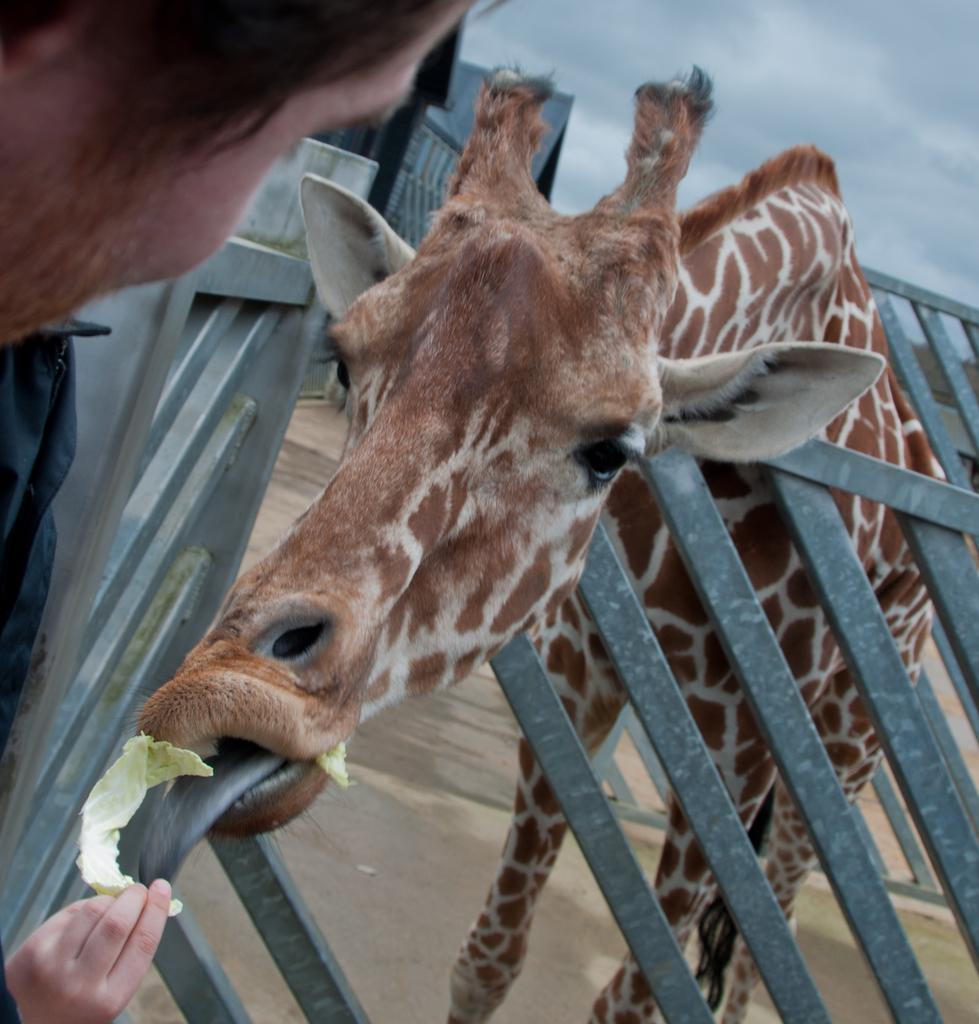What animal can be seen in the image? There is a giraffe in the image. What is the giraffe doing in the image? The giraffe is standing behind a railing and eating. Who is providing food for the giraffe? There is a person holding food for the giraffe. What can be seen in the background of the image? There is a building in the background of the conversation by mentioning the presence of clouds visible at the top of the image. What type of trail can be seen in the image? There is no trail present in the image. 